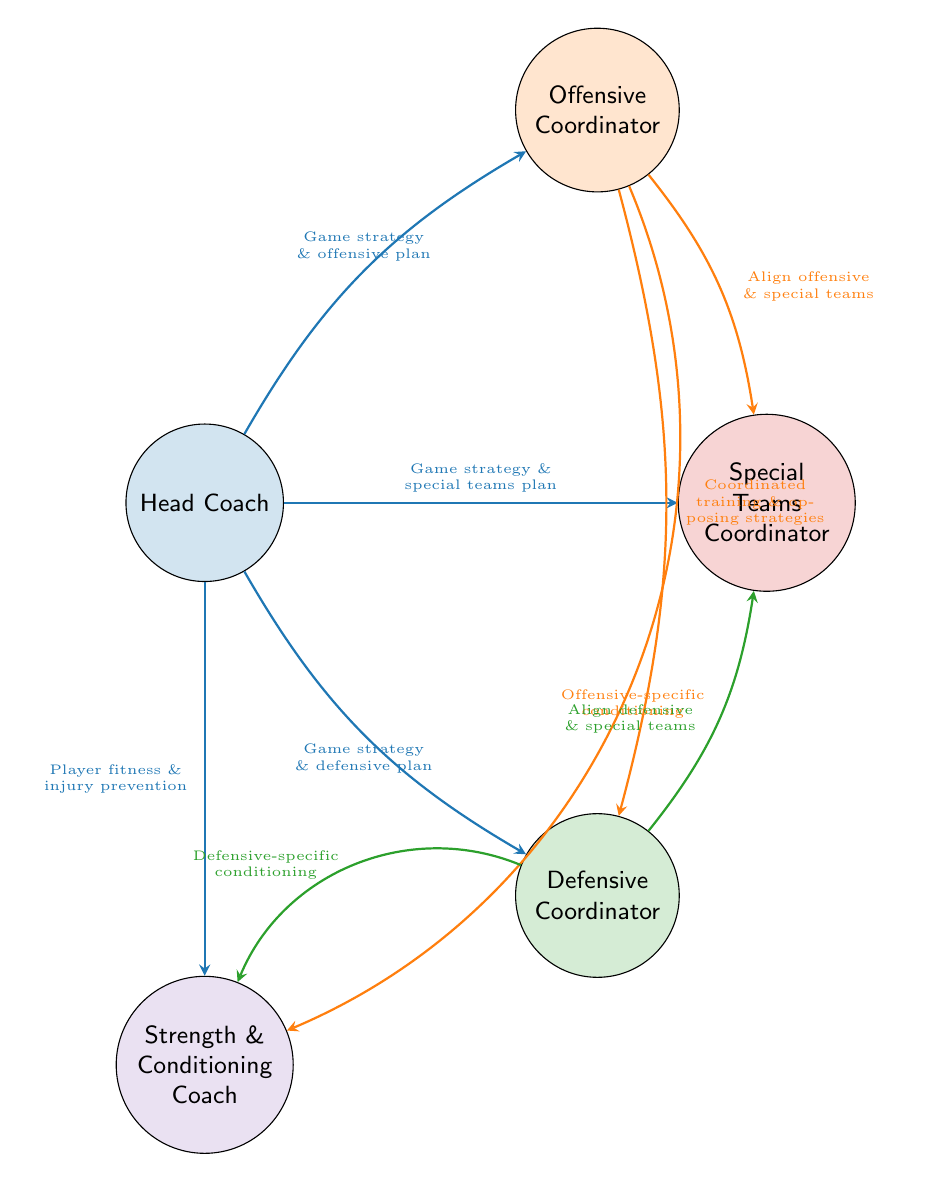What are the five coaching roles represented in the diagram? The nodes in the diagram are Head Coach, Offensive Coordinator, Defensive Coordinator, Special Teams Coordinator, and Strength and Conditioning Coach. Counting the names displayed yields five distinct coaching roles.
Answer: Head Coach, Offensive Coordinator, Defensive Coordinator, Special Teams Coordinator, Strength and Conditioning Coach How many links are there in total? The diagram shows multiple connections between the nodes. By counting each link between the roles, we see there are a total of eight connections.
Answer: 8 What is the value of the connection between the Head Coach and Offensive Coordinator? The diagram indicates that the connection from the Head Coach to the Offensive Coordinator is represented by a value of 3, which is marked next to the arrow indicating the flow of communication.
Answer: 3 Which two coaching roles have a direct communication link to the Strength and Conditioning Coach? Looking at the links, the Strength and Conditioning Coach directly communicates with the Head Coach and both the Offensive and Defensive Coordinators, forming three connections. However, asking for which two implies any two from the three roles; based on values, one could refer to either OC or DC, but HC is also valid.
Answer: Head Coach, Offensive Coordinator (or Defensive Coordinator) What type of discussions does the Head Coach have with the Special Teams Coordinator? The diagram explicitly lists the description next to the connection from the Head Coach to the Special Teams Coordinator as "Game strategy discussions and special teams plan reviews," summarizing their communication focus.
Answer: Game strategy discussions and special teams plan reviews What is the least frequent communication flow in the diagram? By examining the values of all communication flows, we find that several connections have a value of 1, which indicates the least frequent communication. This includes the links from Offensive Coordinator to Defensive Coordinator, Offensive Coordinator to Special Teams Coordinator, Defensive Coordinator to Special Teams Coordinator, and the interactions with both Offensive and Defensive Coordinators to the Strength and Conditioning Coach.
Answer: Value of 1 How many unique communication focuses are described in the relationships? Evaluating the descriptions next to each link, we have several unique focuses: offensive plan reviews, defensive plan reviews, special teams strategy, player fitness strategies, coordinated training sessions, and alignment strategies. Altogether, this sums up to a total of six unique communication focuses.
Answer: 6 Which coaching role interacts most frequently with the Head Coach? By inspecting the connection values involving the Head Coach, it becomes clear that the highest value of 3 occurs in the links with both the Offensive and Defensive Coordinators, indicating they are the most frequently interacting roles with the Head Coach.
Answer: Offensive Coordinator and Defensive Coordinator (tie) 